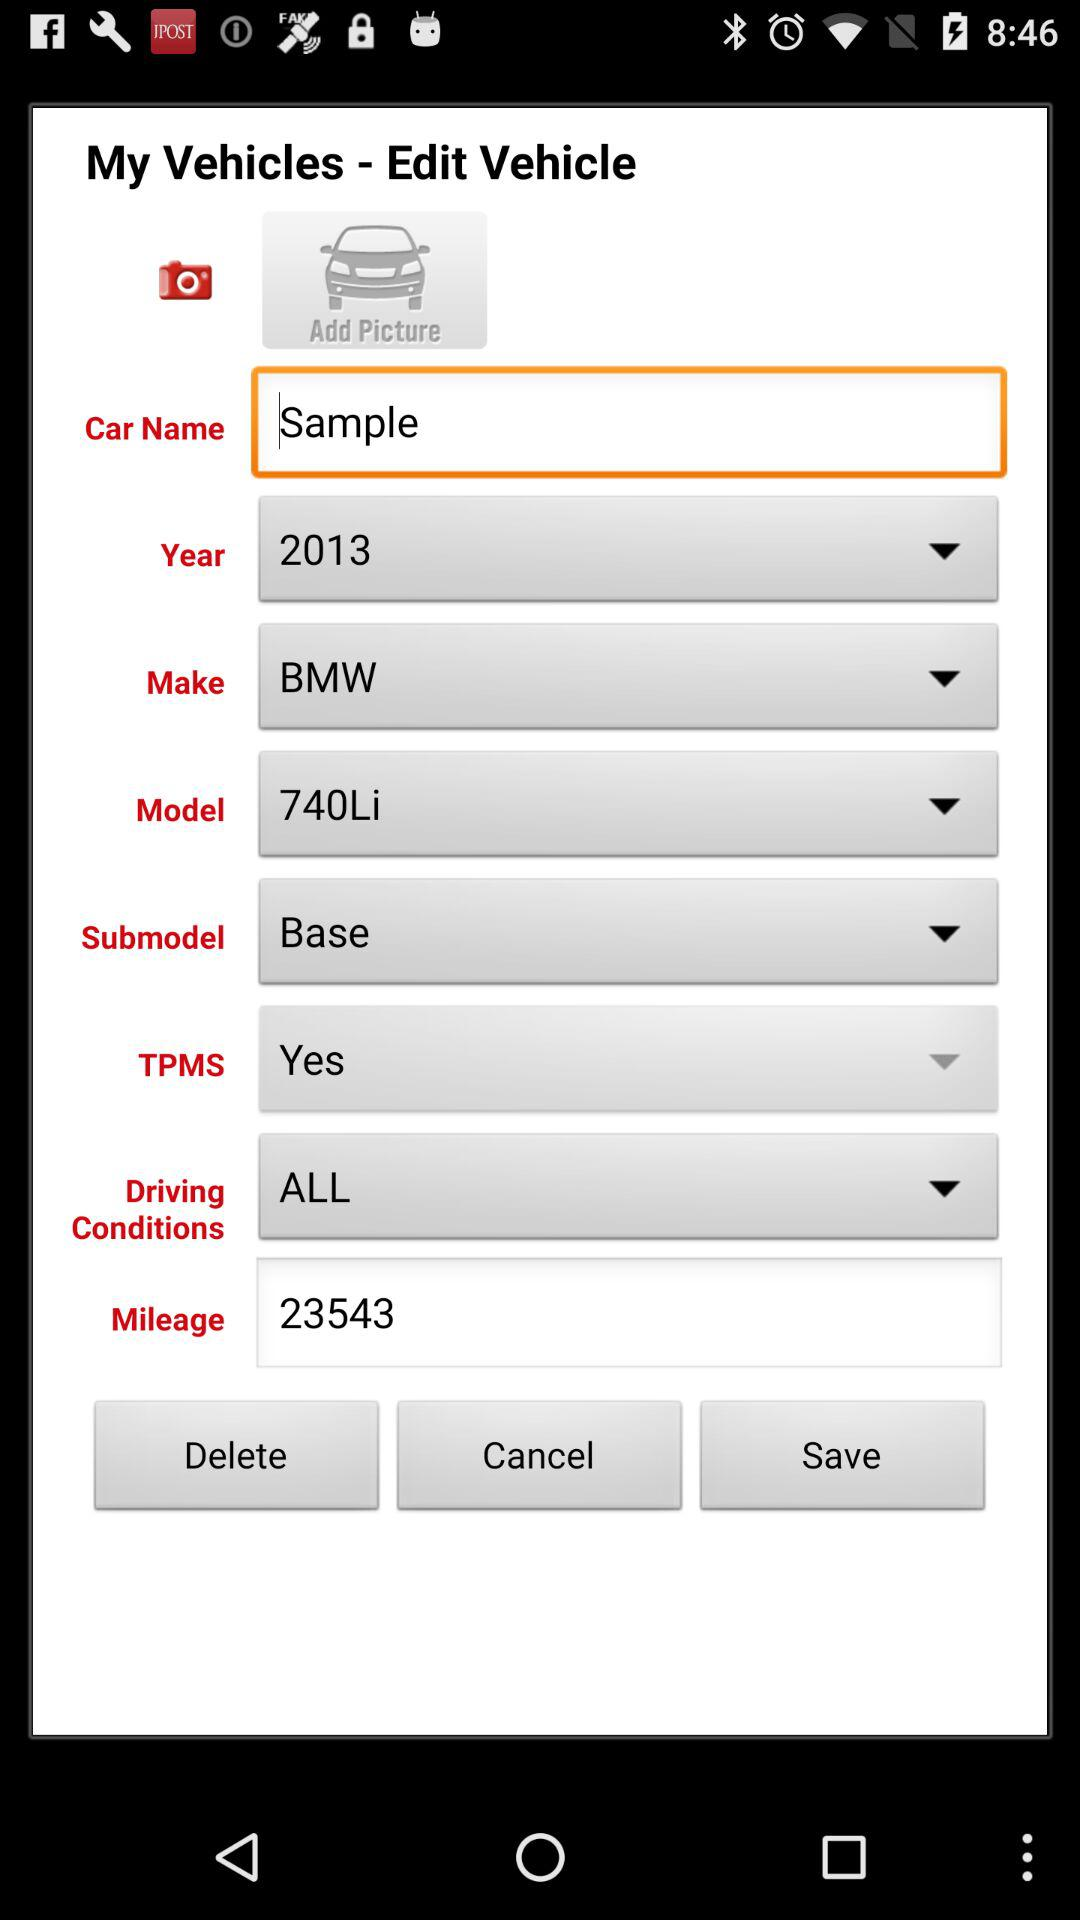What is the mileage? The mileage is 23543. 